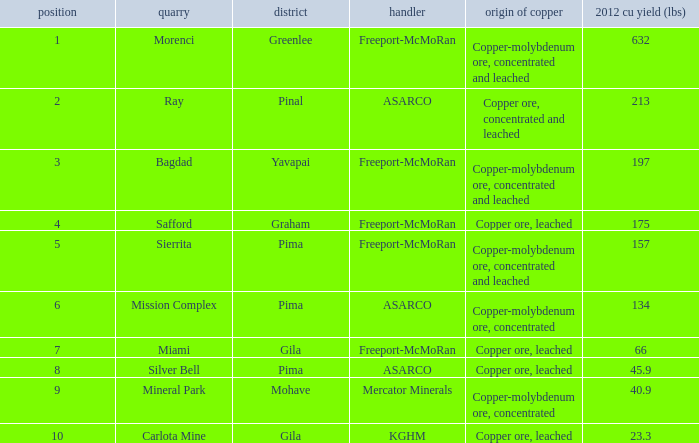Which operator has a rank of 7? Freeport-McMoRan. 